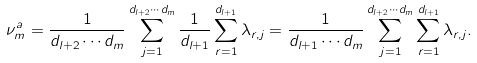<formula> <loc_0><loc_0><loc_500><loc_500>\nu _ { m } ^ { a } = \frac { 1 } { d _ { l + 2 } \cdots d _ { m } } \sum _ { j = 1 } ^ { d _ { l + 2 } \cdots d _ { m } } \frac { 1 } { d _ { l + 1 } } \sum _ { r = 1 } ^ { d _ { l + 1 } } \lambda _ { r , j } = \frac { 1 } { d _ { l + 1 } \cdots d _ { m } } \sum _ { j = 1 } ^ { d _ { l + 2 } \cdots d _ { m } } \sum _ { r = 1 } ^ { d _ { l + 1 } } \lambda _ { r , j } .</formula> 